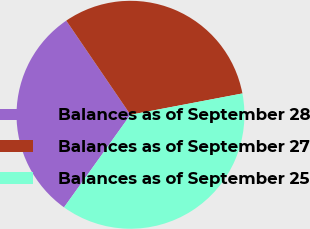Convert chart to OTSL. <chart><loc_0><loc_0><loc_500><loc_500><pie_chart><fcel>Balances as of September 28<fcel>Balances as of September 27<fcel>Balances as of September 25<nl><fcel>30.57%<fcel>31.53%<fcel>37.9%<nl></chart> 